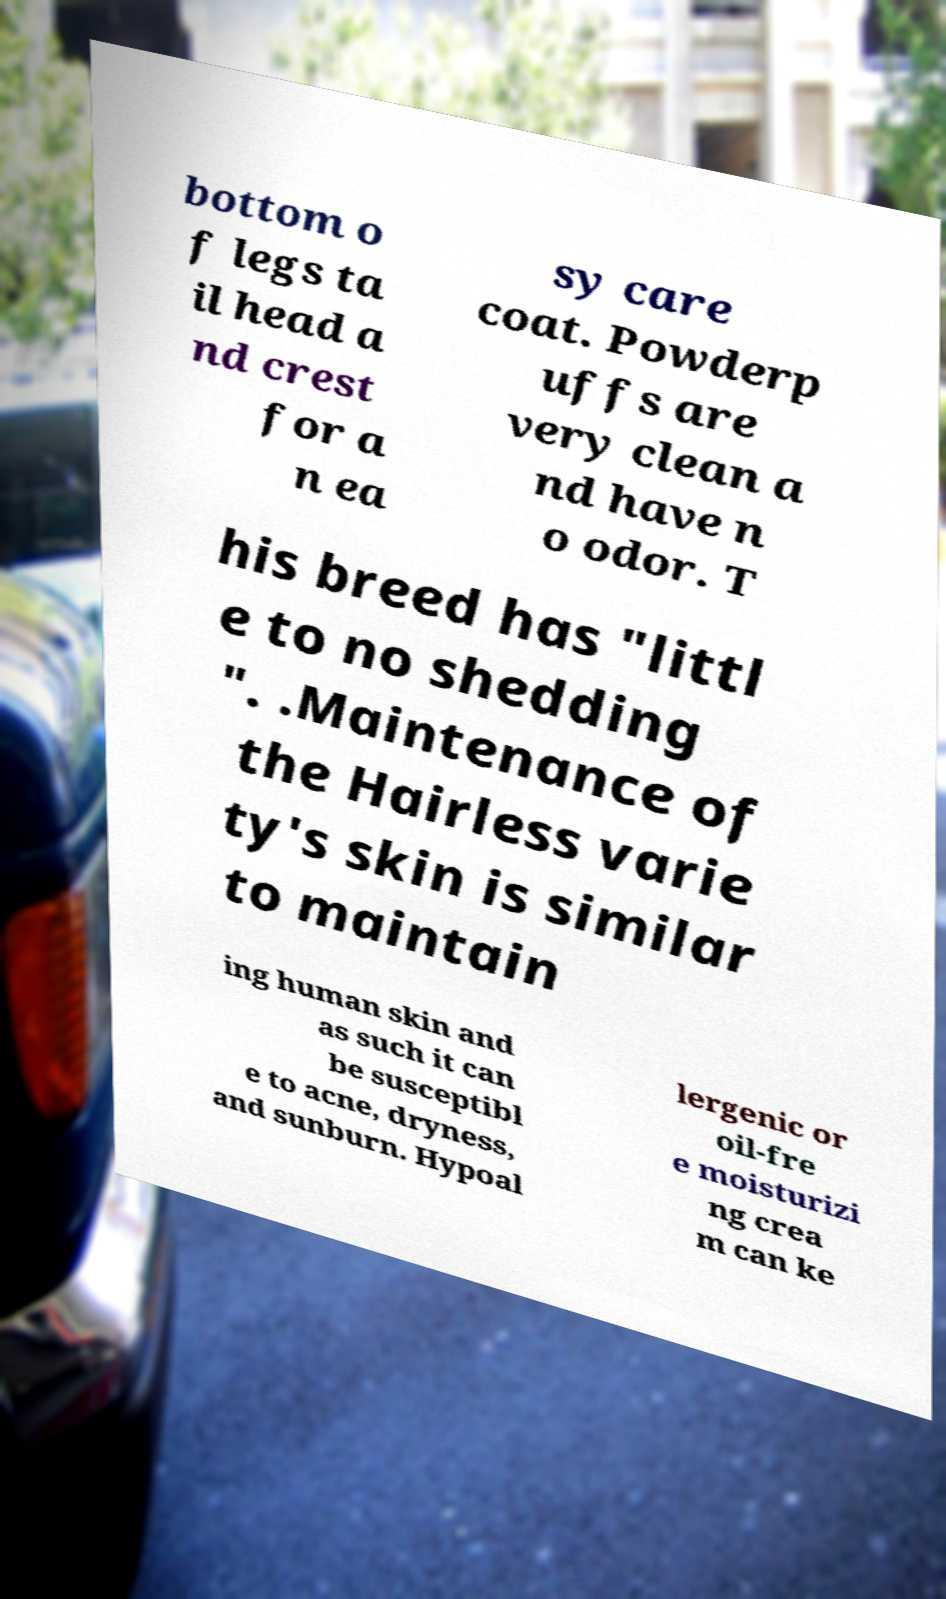What messages or text are displayed in this image? I need them in a readable, typed format. bottom o f legs ta il head a nd crest for a n ea sy care coat. Powderp uffs are very clean a nd have n o odor. T his breed has "littl e to no shedding ". .Maintenance of the Hairless varie ty's skin is similar to maintain ing human skin and as such it can be susceptibl e to acne, dryness, and sunburn. Hypoal lergenic or oil-fre e moisturizi ng crea m can ke 